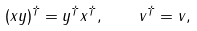<formula> <loc_0><loc_0><loc_500><loc_500>( x y ) ^ { \dagger } = y ^ { \dagger } x ^ { \dagger } , \quad v ^ { \dagger } = v ,</formula> 